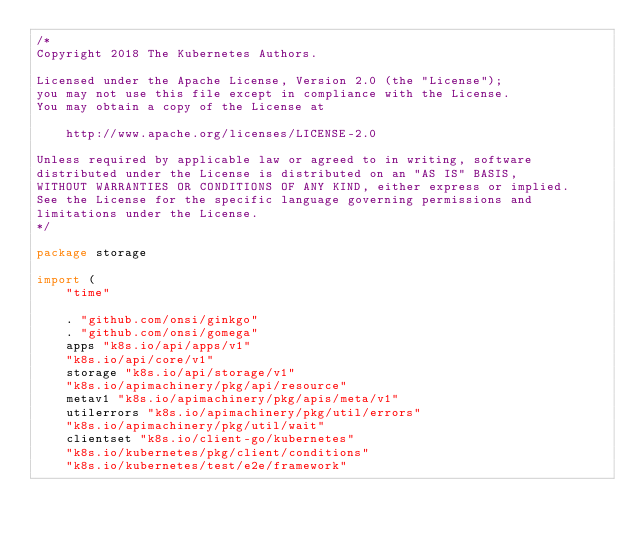Convert code to text. <code><loc_0><loc_0><loc_500><loc_500><_Go_>/*
Copyright 2018 The Kubernetes Authors.

Licensed under the Apache License, Version 2.0 (the "License");
you may not use this file except in compliance with the License.
You may obtain a copy of the License at

    http://www.apache.org/licenses/LICENSE-2.0

Unless required by applicable law or agreed to in writing, software
distributed under the License is distributed on an "AS IS" BASIS,
WITHOUT WARRANTIES OR CONDITIONS OF ANY KIND, either express or implied.
See the License for the specific language governing permissions and
limitations under the License.
*/

package storage

import (
	"time"

	. "github.com/onsi/ginkgo"
	. "github.com/onsi/gomega"
	apps "k8s.io/api/apps/v1"
	"k8s.io/api/core/v1"
	storage "k8s.io/api/storage/v1"
	"k8s.io/apimachinery/pkg/api/resource"
	metav1 "k8s.io/apimachinery/pkg/apis/meta/v1"
	utilerrors "k8s.io/apimachinery/pkg/util/errors"
	"k8s.io/apimachinery/pkg/util/wait"
	clientset "k8s.io/client-go/kubernetes"
	"k8s.io/kubernetes/pkg/client/conditions"
	"k8s.io/kubernetes/test/e2e/framework"</code> 